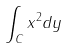Convert formula to latex. <formula><loc_0><loc_0><loc_500><loc_500>\int _ { C } x ^ { 2 } d y</formula> 